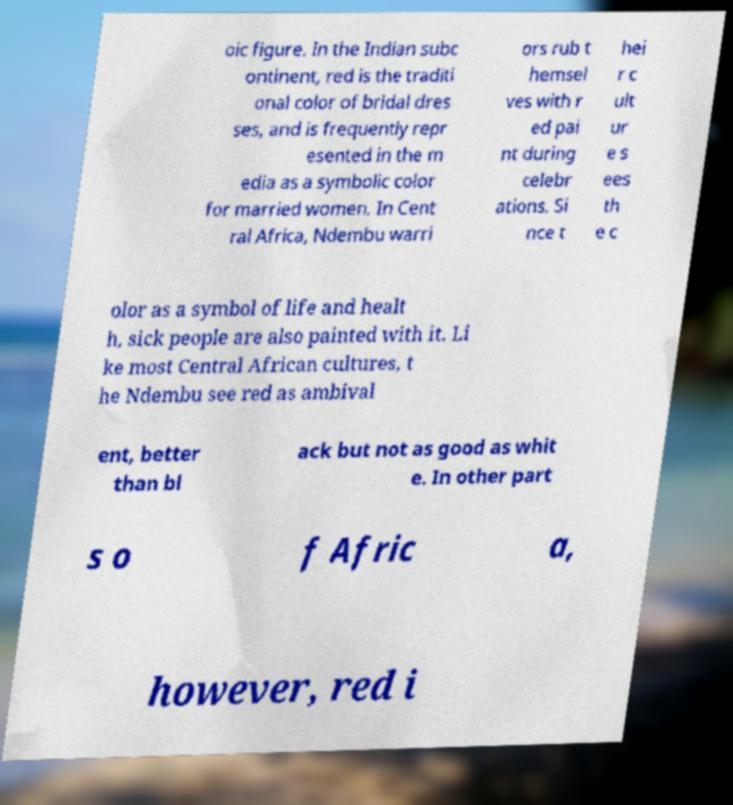Can you accurately transcribe the text from the provided image for me? oic figure. In the Indian subc ontinent, red is the traditi onal color of bridal dres ses, and is frequently repr esented in the m edia as a symbolic color for married women. In Cent ral Africa, Ndembu warri ors rub t hemsel ves with r ed pai nt during celebr ations. Si nce t hei r c ult ur e s ees th e c olor as a symbol of life and healt h, sick people are also painted with it. Li ke most Central African cultures, t he Ndembu see red as ambival ent, better than bl ack but not as good as whit e. In other part s o f Afric a, however, red i 